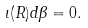<formula> <loc_0><loc_0><loc_500><loc_500>\iota ( R ) d \beta = 0 .</formula> 